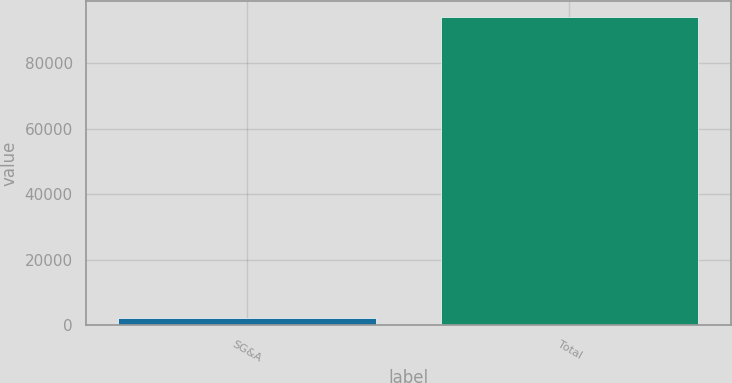Convert chart. <chart><loc_0><loc_0><loc_500><loc_500><bar_chart><fcel>SG&A<fcel>Total<nl><fcel>2249<fcel>94100<nl></chart> 